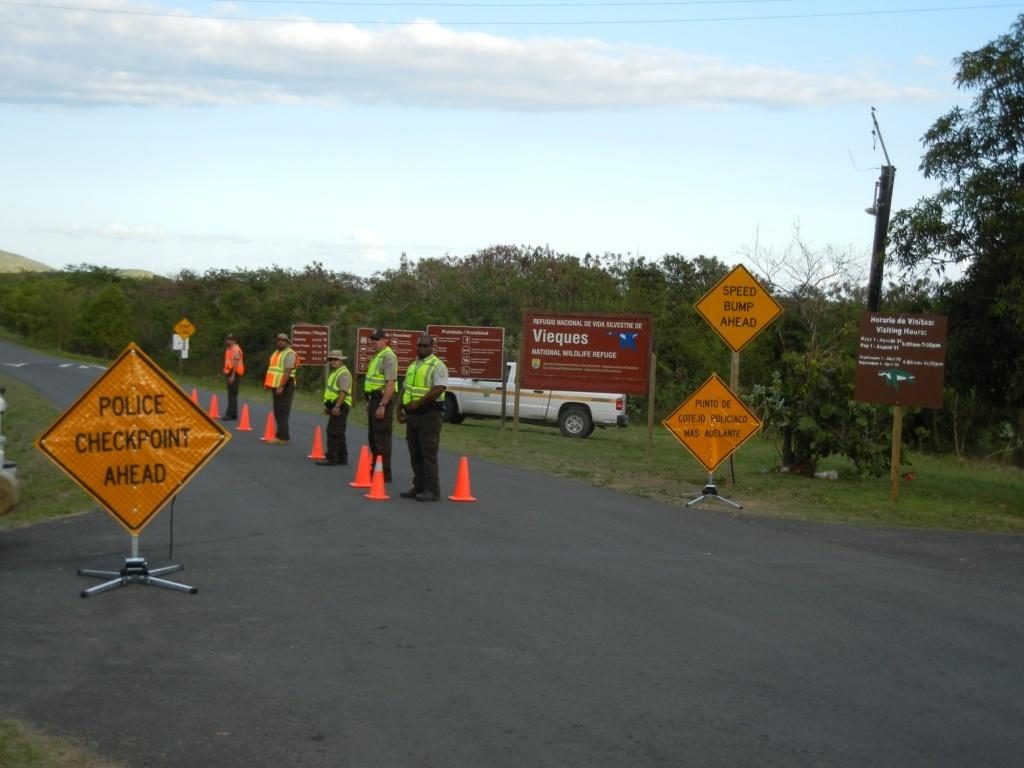<image>
Create a compact narrative representing the image presented. Policemen line the road in front of a yellow sign that reads "police checkpoint ahead" 